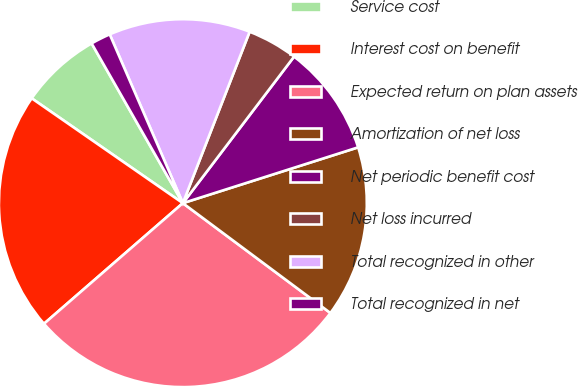Convert chart. <chart><loc_0><loc_0><loc_500><loc_500><pie_chart><fcel>Service cost<fcel>Interest cost on benefit<fcel>Expected return on plan assets<fcel>Amortization of net loss<fcel>Net periodic benefit cost<fcel>Net loss incurred<fcel>Total recognized in other<fcel>Total recognized in net<nl><fcel>7.09%<fcel>21.03%<fcel>28.43%<fcel>15.09%<fcel>9.76%<fcel>4.42%<fcel>12.42%<fcel>1.75%<nl></chart> 